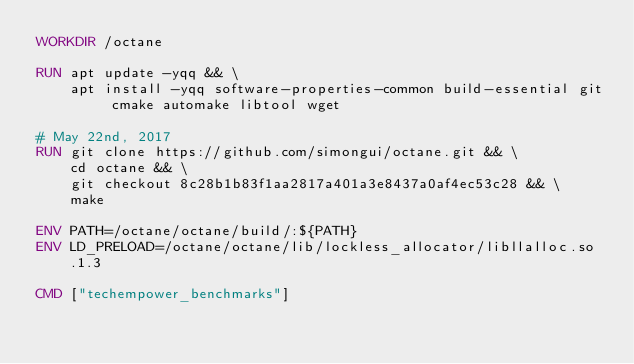<code> <loc_0><loc_0><loc_500><loc_500><_Dockerfile_>WORKDIR /octane

RUN apt update -yqq && \
    apt install -yqq software-properties-common build-essential git cmake automake libtool wget

# May 22nd, 2017
RUN git clone https://github.com/simongui/octane.git && \
    cd octane && \
    git checkout 8c28b1b83f1aa2817a401a3e8437a0af4ec53c28 && \
    make

ENV PATH=/octane/octane/build/:${PATH}
ENV LD_PRELOAD=/octane/octane/lib/lockless_allocator/libllalloc.so.1.3

CMD ["techempower_benchmarks"]
</code> 